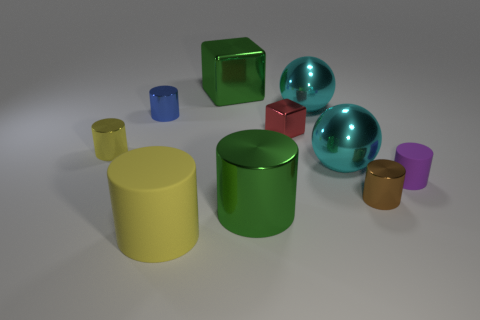Subtract all small purple cylinders. How many cylinders are left? 5 Subtract all blue spheres. How many yellow cylinders are left? 2 Subtract 4 cylinders. How many cylinders are left? 2 Subtract all red blocks. How many blocks are left? 1 Subtract all balls. How many objects are left? 8 Subtract all brown cylinders. Subtract all cyan metallic balls. How many objects are left? 7 Add 4 small cubes. How many small cubes are left? 5 Add 5 big blue cubes. How many big blue cubes exist? 5 Subtract 2 yellow cylinders. How many objects are left? 8 Subtract all red cylinders. Subtract all brown balls. How many cylinders are left? 6 